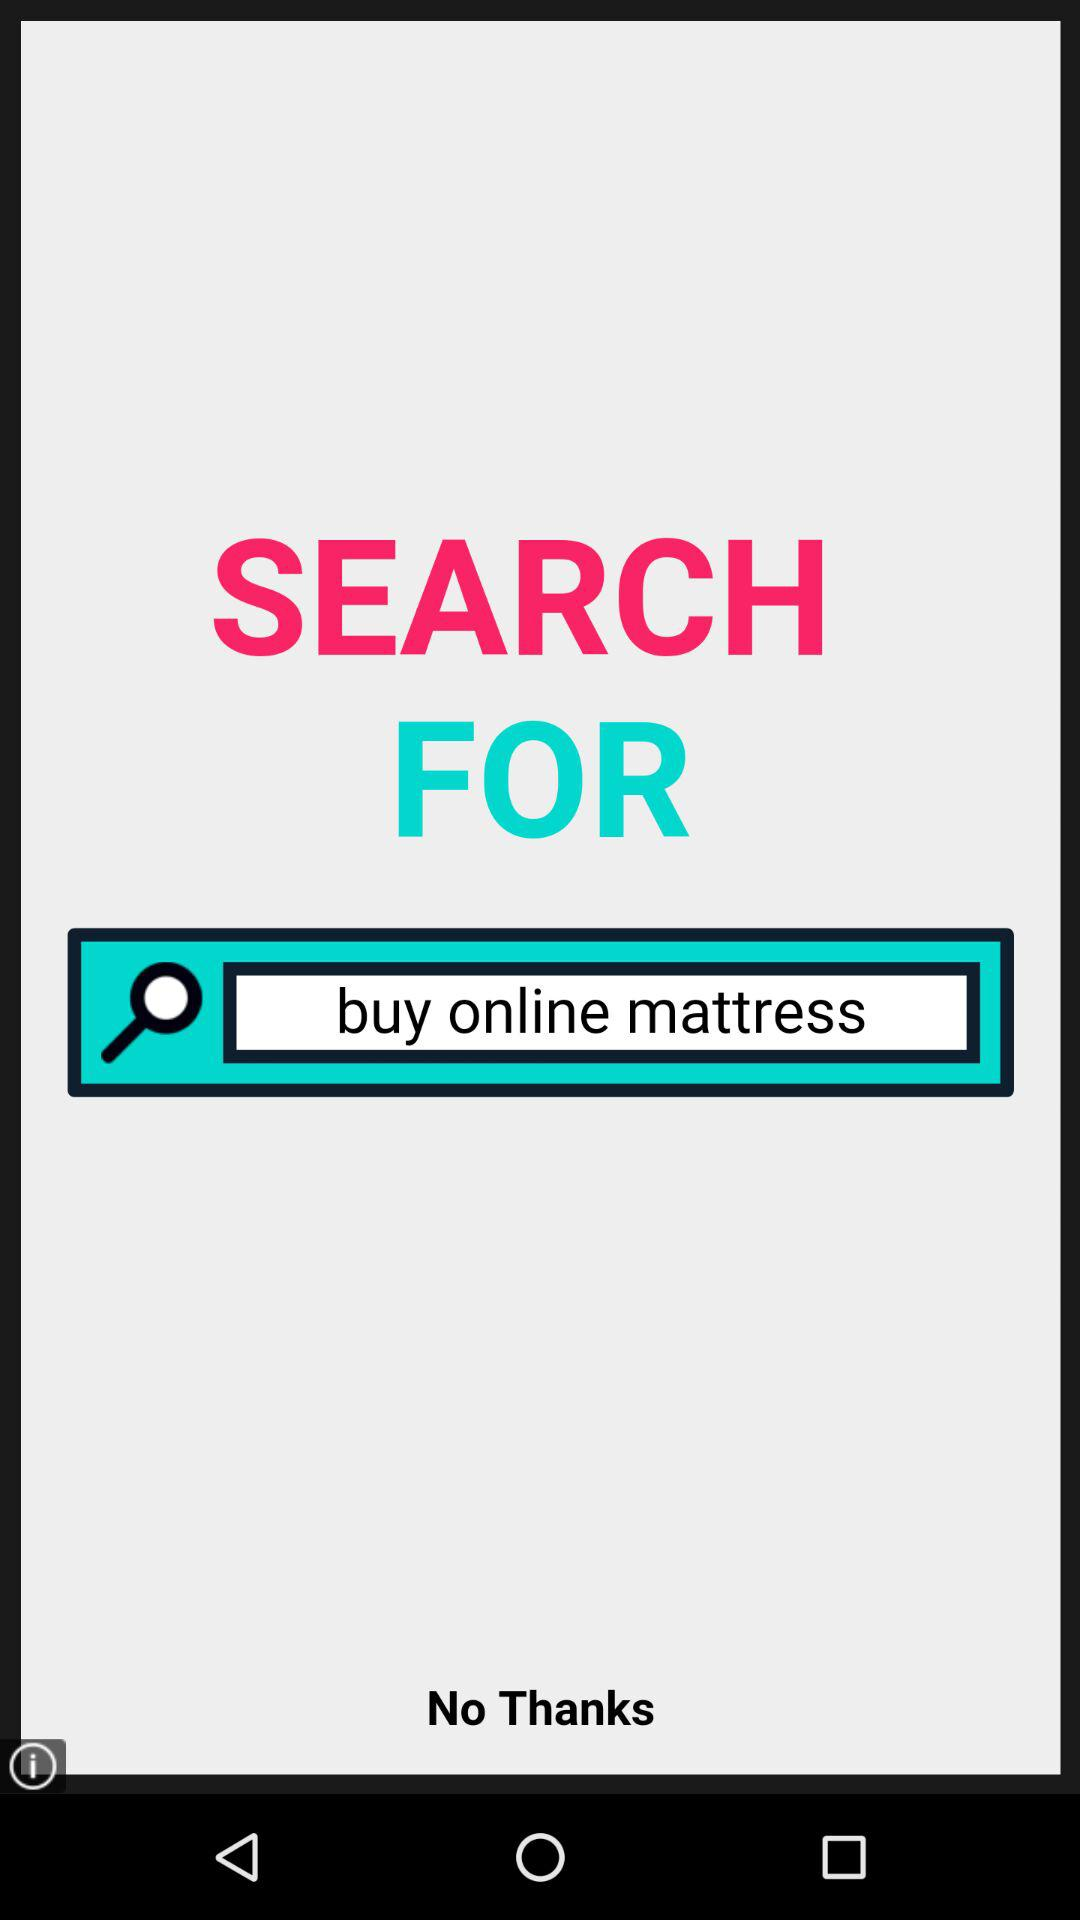What are we searching to buy? You are searching to buy an online mattress. 